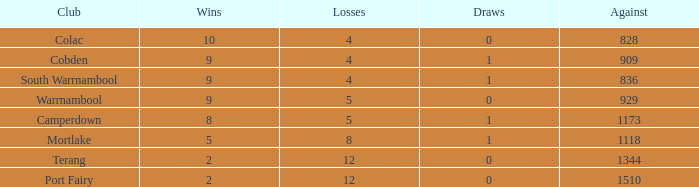When the opposing team scores fewer than 1510 points, what is port fairy's total win count? None. 